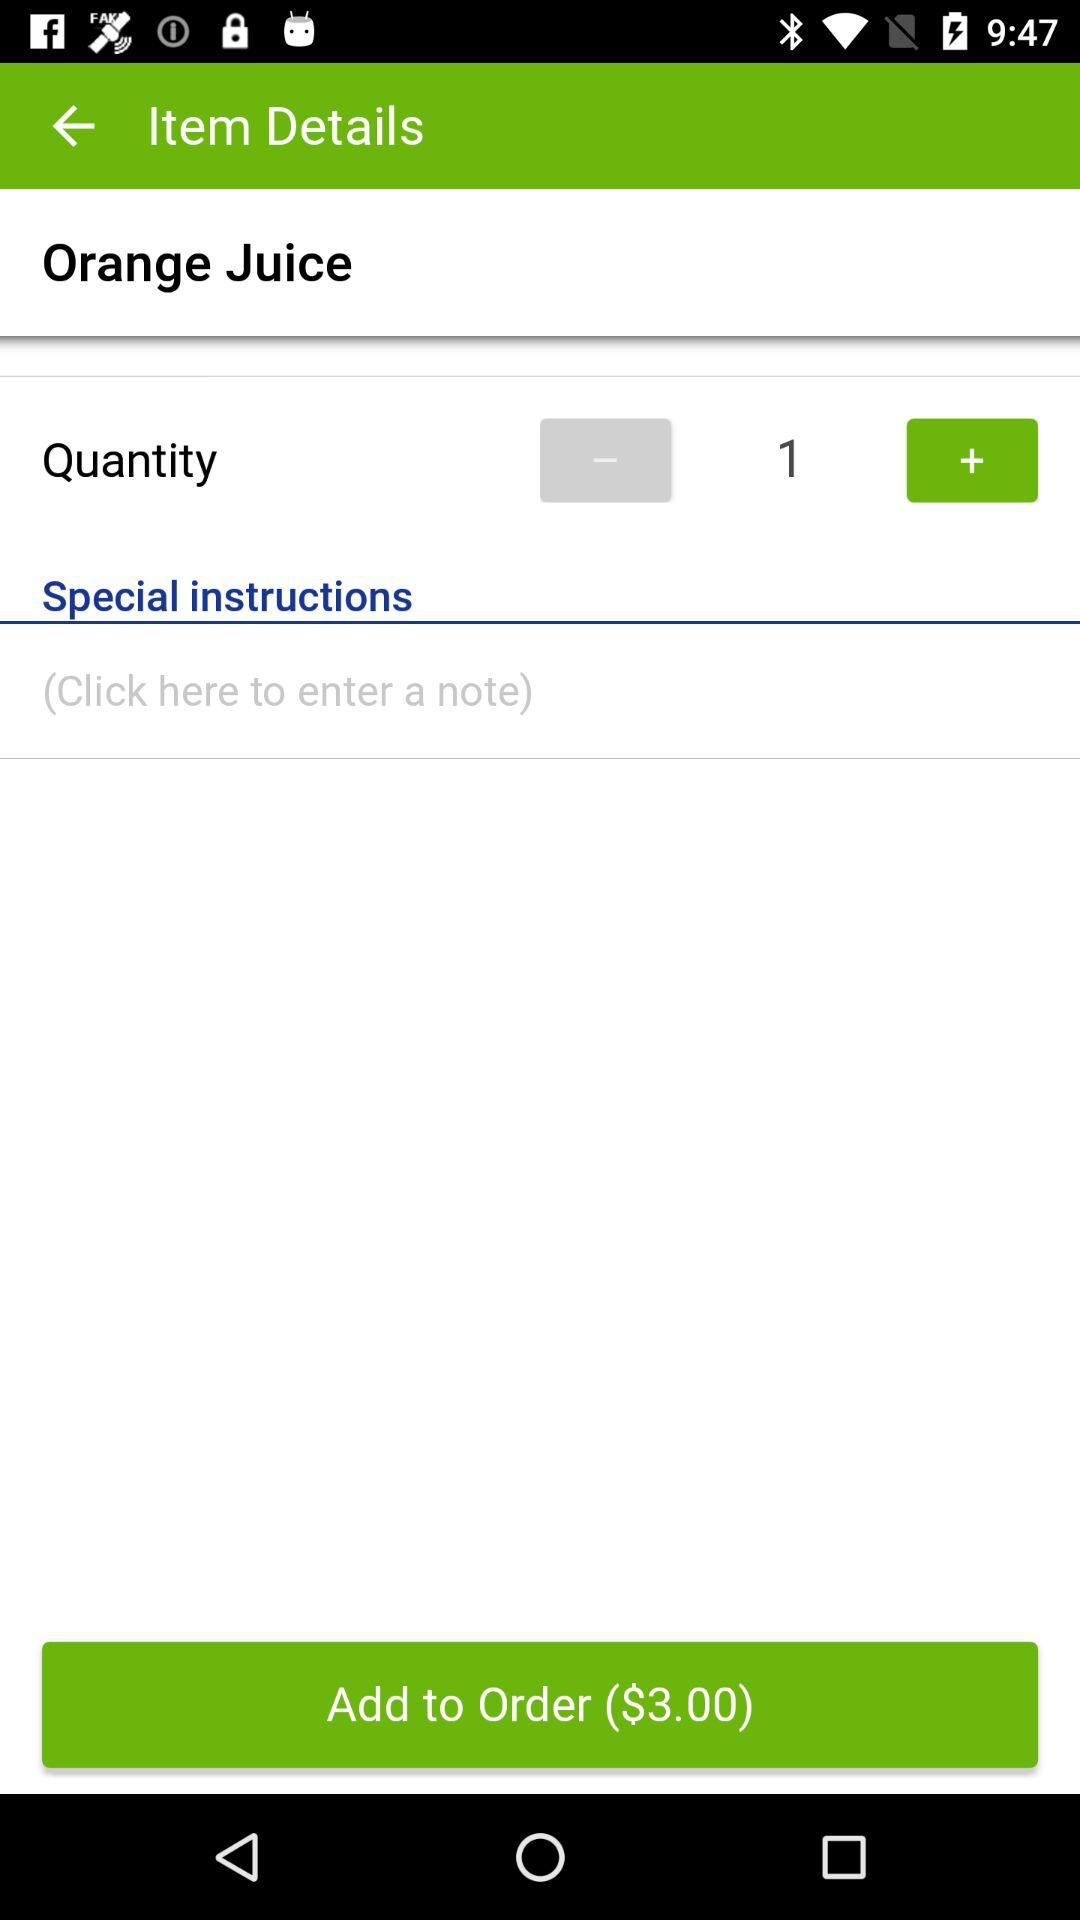How many liters is the orange juice?
When the provided information is insufficient, respond with <no answer>. <no answer> 